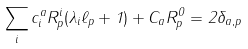Convert formula to latex. <formula><loc_0><loc_0><loc_500><loc_500>\sum _ { i } c ^ { a } _ { i } R ^ { i } _ { p } ( \lambda _ { i } \ell _ { p } + 1 ) + C _ { a } R ^ { 0 } _ { p } = 2 \delta _ { { a } , { p } }</formula> 